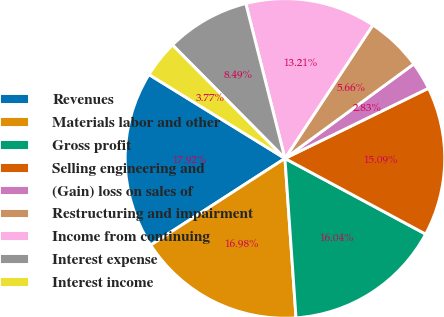Convert chart to OTSL. <chart><loc_0><loc_0><loc_500><loc_500><pie_chart><fcel>Revenues<fcel>Materials labor and other<fcel>Gross profit<fcel>Selling engineering and<fcel>(Gain) loss on sales of<fcel>Restructuring and impairment<fcel>Income from continuing<fcel>Interest expense<fcel>Interest income<nl><fcel>17.92%<fcel>16.98%<fcel>16.04%<fcel>15.09%<fcel>2.83%<fcel>5.66%<fcel>13.21%<fcel>8.49%<fcel>3.77%<nl></chart> 